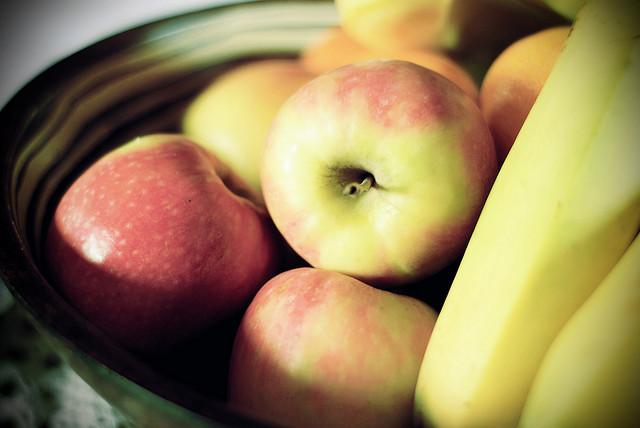What kind of apple is seen?
Answer briefly. Red. What contains the fruit?
Write a very short answer. Bowl. How many different types of fruit are there?
Give a very brief answer. 3. What are the fruits in?
Answer briefly. Bowl. 